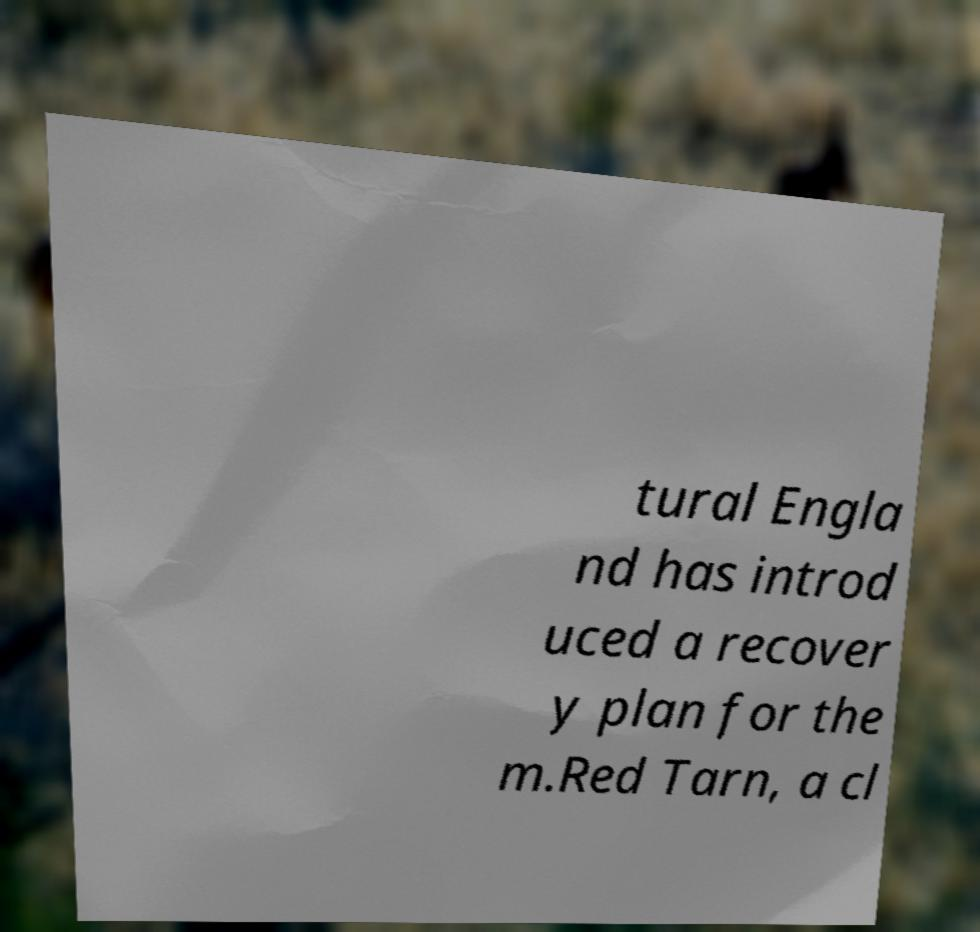For documentation purposes, I need the text within this image transcribed. Could you provide that? tural Engla nd has introd uced a recover y plan for the m.Red Tarn, a cl 